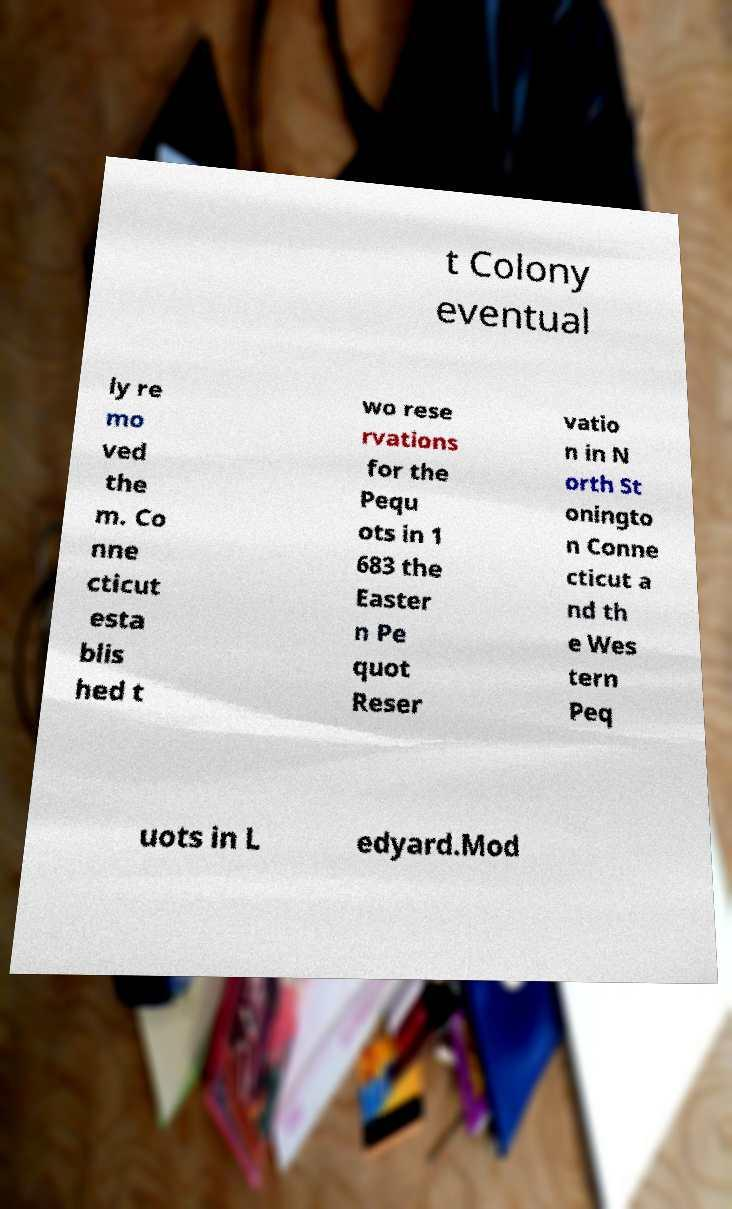What messages or text are displayed in this image? I need them in a readable, typed format. t Colony eventual ly re mo ved the m. Co nne cticut esta blis hed t wo rese rvations for the Pequ ots in 1 683 the Easter n Pe quot Reser vatio n in N orth St oningto n Conne cticut a nd th e Wes tern Peq uots in L edyard.Mod 